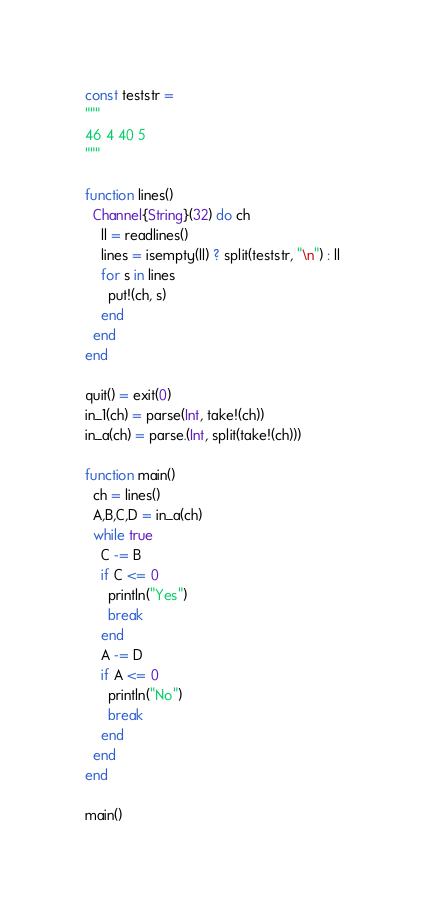Convert code to text. <code><loc_0><loc_0><loc_500><loc_500><_Julia_>const teststr = 
"""
46 4 40 5
"""

function lines()
  Channel{String}(32) do ch
    ll = readlines()
    lines = isempty(ll) ? split(teststr, "\n") : ll
    for s in lines
      put!(ch, s)
    end
  end
end

quit() = exit(0)
in_1(ch) = parse(Int, take!(ch))
in_a(ch) = parse.(Int, split(take!(ch)))

function main()
  ch = lines()
  A,B,C,D = in_a(ch)
  while true
    C -= B
    if C <= 0
      println("Yes")
      break
    end
    A -= D
    if A <= 0
      println("No")
      break
    end
  end
end

main()
</code> 